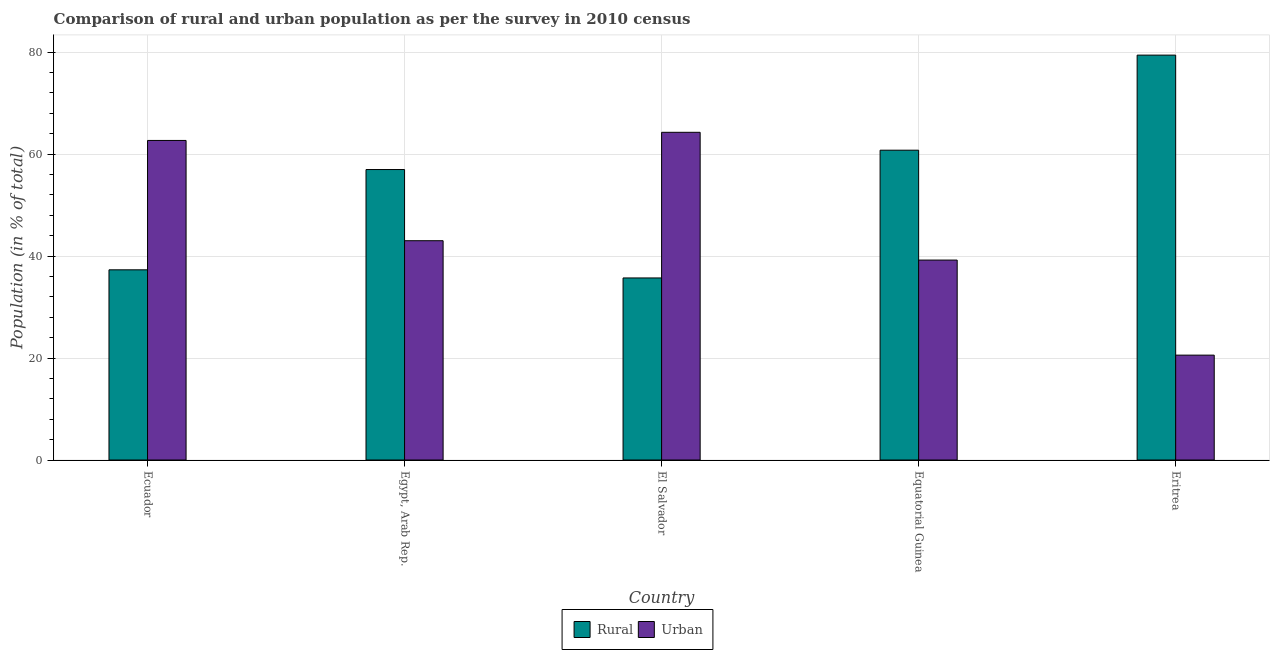How many different coloured bars are there?
Offer a very short reply. 2. How many groups of bars are there?
Provide a succinct answer. 5. Are the number of bars per tick equal to the number of legend labels?
Keep it short and to the point. Yes. How many bars are there on the 1st tick from the right?
Give a very brief answer. 2. What is the label of the 2nd group of bars from the left?
Offer a very short reply. Egypt, Arab Rep. What is the rural population in El Salvador?
Your answer should be very brief. 35.71. Across all countries, what is the maximum rural population?
Offer a very short reply. 79.43. Across all countries, what is the minimum urban population?
Ensure brevity in your answer.  20.57. In which country was the urban population maximum?
Ensure brevity in your answer.  El Salvador. In which country was the urban population minimum?
Provide a short and direct response. Eritrea. What is the total urban population in the graph?
Your answer should be compact. 229.79. What is the difference between the urban population in Ecuador and that in Equatorial Guinea?
Your response must be concise. 23.47. What is the difference between the urban population in El Salvador and the rural population in Egypt, Arab Rep.?
Make the answer very short. 7.3. What is the average urban population per country?
Your response must be concise. 45.96. What is the difference between the rural population and urban population in Ecuador?
Provide a succinct answer. -25.38. What is the ratio of the rural population in Egypt, Arab Rep. to that in Eritrea?
Your answer should be compact. 0.72. Is the difference between the urban population in Egypt, Arab Rep. and Eritrea greater than the difference between the rural population in Egypt, Arab Rep. and Eritrea?
Your answer should be compact. Yes. What is the difference between the highest and the second highest urban population?
Give a very brief answer. 1.6. What is the difference between the highest and the lowest urban population?
Your answer should be compact. 43.71. In how many countries, is the rural population greater than the average rural population taken over all countries?
Provide a short and direct response. 3. Is the sum of the urban population in El Salvador and Eritrea greater than the maximum rural population across all countries?
Provide a short and direct response. Yes. What does the 1st bar from the left in Eritrea represents?
Provide a short and direct response. Rural. What does the 2nd bar from the right in Egypt, Arab Rep. represents?
Your answer should be compact. Rural. How many bars are there?
Provide a succinct answer. 10. Are all the bars in the graph horizontal?
Your answer should be very brief. No. Are the values on the major ticks of Y-axis written in scientific E-notation?
Offer a very short reply. No. Does the graph contain any zero values?
Your response must be concise. No. Does the graph contain grids?
Ensure brevity in your answer.  Yes. What is the title of the graph?
Provide a succinct answer. Comparison of rural and urban population as per the survey in 2010 census. Does "Investments" appear as one of the legend labels in the graph?
Keep it short and to the point. No. What is the label or title of the Y-axis?
Your response must be concise. Population (in % of total). What is the Population (in % of total) of Rural in Ecuador?
Offer a very short reply. 37.31. What is the Population (in % of total) of Urban in Ecuador?
Give a very brief answer. 62.69. What is the Population (in % of total) in Rural in Egypt, Arab Rep.?
Provide a short and direct response. 56.98. What is the Population (in % of total) of Urban in Egypt, Arab Rep.?
Provide a short and direct response. 43.02. What is the Population (in % of total) of Rural in El Salvador?
Keep it short and to the point. 35.71. What is the Population (in % of total) in Urban in El Salvador?
Your response must be concise. 64.29. What is the Population (in % of total) in Rural in Equatorial Guinea?
Give a very brief answer. 60.78. What is the Population (in % of total) of Urban in Equatorial Guinea?
Give a very brief answer. 39.22. What is the Population (in % of total) of Rural in Eritrea?
Your answer should be compact. 79.43. What is the Population (in % of total) of Urban in Eritrea?
Your answer should be compact. 20.57. Across all countries, what is the maximum Population (in % of total) in Rural?
Ensure brevity in your answer.  79.43. Across all countries, what is the maximum Population (in % of total) of Urban?
Your answer should be very brief. 64.29. Across all countries, what is the minimum Population (in % of total) in Rural?
Your answer should be compact. 35.71. Across all countries, what is the minimum Population (in % of total) in Urban?
Keep it short and to the point. 20.57. What is the total Population (in % of total) of Rural in the graph?
Offer a very short reply. 270.21. What is the total Population (in % of total) of Urban in the graph?
Ensure brevity in your answer.  229.79. What is the difference between the Population (in % of total) in Rural in Ecuador and that in Egypt, Arab Rep.?
Provide a succinct answer. -19.67. What is the difference between the Population (in % of total) in Urban in Ecuador and that in Egypt, Arab Rep.?
Make the answer very short. 19.67. What is the difference between the Population (in % of total) of Rural in Ecuador and that in El Salvador?
Offer a terse response. 1.6. What is the difference between the Population (in % of total) of Urban in Ecuador and that in El Salvador?
Your answer should be very brief. -1.6. What is the difference between the Population (in % of total) in Rural in Ecuador and that in Equatorial Guinea?
Ensure brevity in your answer.  -23.47. What is the difference between the Population (in % of total) in Urban in Ecuador and that in Equatorial Guinea?
Keep it short and to the point. 23.47. What is the difference between the Population (in % of total) in Rural in Ecuador and that in Eritrea?
Make the answer very short. -42.12. What is the difference between the Population (in % of total) in Urban in Ecuador and that in Eritrea?
Your answer should be very brief. 42.12. What is the difference between the Population (in % of total) in Rural in Egypt, Arab Rep. and that in El Salvador?
Your answer should be very brief. 21.27. What is the difference between the Population (in % of total) in Urban in Egypt, Arab Rep. and that in El Salvador?
Give a very brief answer. -21.27. What is the difference between the Population (in % of total) of Rural in Egypt, Arab Rep. and that in Equatorial Guinea?
Provide a succinct answer. -3.8. What is the difference between the Population (in % of total) of Urban in Egypt, Arab Rep. and that in Equatorial Guinea?
Your response must be concise. 3.8. What is the difference between the Population (in % of total) in Rural in Egypt, Arab Rep. and that in Eritrea?
Your answer should be very brief. -22.45. What is the difference between the Population (in % of total) of Urban in Egypt, Arab Rep. and that in Eritrea?
Make the answer very short. 22.45. What is the difference between the Population (in % of total) of Rural in El Salvador and that in Equatorial Guinea?
Provide a succinct answer. -25.06. What is the difference between the Population (in % of total) of Urban in El Salvador and that in Equatorial Guinea?
Your answer should be compact. 25.06. What is the difference between the Population (in % of total) in Rural in El Salvador and that in Eritrea?
Offer a very short reply. -43.71. What is the difference between the Population (in % of total) in Urban in El Salvador and that in Eritrea?
Keep it short and to the point. 43.71. What is the difference between the Population (in % of total) of Rural in Equatorial Guinea and that in Eritrea?
Your answer should be compact. -18.65. What is the difference between the Population (in % of total) in Urban in Equatorial Guinea and that in Eritrea?
Ensure brevity in your answer.  18.65. What is the difference between the Population (in % of total) of Rural in Ecuador and the Population (in % of total) of Urban in Egypt, Arab Rep.?
Provide a succinct answer. -5.71. What is the difference between the Population (in % of total) of Rural in Ecuador and the Population (in % of total) of Urban in El Salvador?
Your answer should be very brief. -26.98. What is the difference between the Population (in % of total) in Rural in Ecuador and the Population (in % of total) in Urban in Equatorial Guinea?
Offer a very short reply. -1.91. What is the difference between the Population (in % of total) of Rural in Ecuador and the Population (in % of total) of Urban in Eritrea?
Your answer should be very brief. 16.74. What is the difference between the Population (in % of total) in Rural in Egypt, Arab Rep. and the Population (in % of total) in Urban in El Salvador?
Keep it short and to the point. -7.3. What is the difference between the Population (in % of total) in Rural in Egypt, Arab Rep. and the Population (in % of total) in Urban in Equatorial Guinea?
Give a very brief answer. 17.76. What is the difference between the Population (in % of total) in Rural in Egypt, Arab Rep. and the Population (in % of total) in Urban in Eritrea?
Give a very brief answer. 36.41. What is the difference between the Population (in % of total) in Rural in El Salvador and the Population (in % of total) in Urban in Equatorial Guinea?
Keep it short and to the point. -3.51. What is the difference between the Population (in % of total) in Rural in El Salvador and the Population (in % of total) in Urban in Eritrea?
Your answer should be compact. 15.14. What is the difference between the Population (in % of total) in Rural in Equatorial Guinea and the Population (in % of total) in Urban in Eritrea?
Offer a terse response. 40.2. What is the average Population (in % of total) in Rural per country?
Offer a very short reply. 54.04. What is the average Population (in % of total) in Urban per country?
Your answer should be compact. 45.96. What is the difference between the Population (in % of total) in Rural and Population (in % of total) in Urban in Ecuador?
Provide a short and direct response. -25.38. What is the difference between the Population (in % of total) in Rural and Population (in % of total) in Urban in Egypt, Arab Rep.?
Your answer should be compact. 13.96. What is the difference between the Population (in % of total) in Rural and Population (in % of total) in Urban in El Salvador?
Provide a succinct answer. -28.57. What is the difference between the Population (in % of total) of Rural and Population (in % of total) of Urban in Equatorial Guinea?
Ensure brevity in your answer.  21.55. What is the difference between the Population (in % of total) of Rural and Population (in % of total) of Urban in Eritrea?
Your answer should be compact. 58.86. What is the ratio of the Population (in % of total) of Rural in Ecuador to that in Egypt, Arab Rep.?
Your answer should be very brief. 0.65. What is the ratio of the Population (in % of total) of Urban in Ecuador to that in Egypt, Arab Rep.?
Give a very brief answer. 1.46. What is the ratio of the Population (in % of total) in Rural in Ecuador to that in El Salvador?
Make the answer very short. 1.04. What is the ratio of the Population (in % of total) in Urban in Ecuador to that in El Salvador?
Your response must be concise. 0.98. What is the ratio of the Population (in % of total) in Rural in Ecuador to that in Equatorial Guinea?
Your response must be concise. 0.61. What is the ratio of the Population (in % of total) of Urban in Ecuador to that in Equatorial Guinea?
Keep it short and to the point. 1.6. What is the ratio of the Population (in % of total) in Rural in Ecuador to that in Eritrea?
Offer a terse response. 0.47. What is the ratio of the Population (in % of total) of Urban in Ecuador to that in Eritrea?
Provide a succinct answer. 3.05. What is the ratio of the Population (in % of total) of Rural in Egypt, Arab Rep. to that in El Salvador?
Offer a very short reply. 1.6. What is the ratio of the Population (in % of total) of Urban in Egypt, Arab Rep. to that in El Salvador?
Your response must be concise. 0.67. What is the ratio of the Population (in % of total) in Urban in Egypt, Arab Rep. to that in Equatorial Guinea?
Offer a very short reply. 1.1. What is the ratio of the Population (in % of total) of Rural in Egypt, Arab Rep. to that in Eritrea?
Offer a terse response. 0.72. What is the ratio of the Population (in % of total) in Urban in Egypt, Arab Rep. to that in Eritrea?
Your response must be concise. 2.09. What is the ratio of the Population (in % of total) of Rural in El Salvador to that in Equatorial Guinea?
Offer a terse response. 0.59. What is the ratio of the Population (in % of total) in Urban in El Salvador to that in Equatorial Guinea?
Offer a very short reply. 1.64. What is the ratio of the Population (in % of total) in Rural in El Salvador to that in Eritrea?
Offer a very short reply. 0.45. What is the ratio of the Population (in % of total) in Urban in El Salvador to that in Eritrea?
Offer a very short reply. 3.12. What is the ratio of the Population (in % of total) of Rural in Equatorial Guinea to that in Eritrea?
Offer a terse response. 0.77. What is the ratio of the Population (in % of total) of Urban in Equatorial Guinea to that in Eritrea?
Your answer should be very brief. 1.91. What is the difference between the highest and the second highest Population (in % of total) of Rural?
Offer a very short reply. 18.65. What is the difference between the highest and the second highest Population (in % of total) in Urban?
Provide a short and direct response. 1.6. What is the difference between the highest and the lowest Population (in % of total) in Rural?
Offer a very short reply. 43.71. What is the difference between the highest and the lowest Population (in % of total) in Urban?
Your answer should be compact. 43.71. 